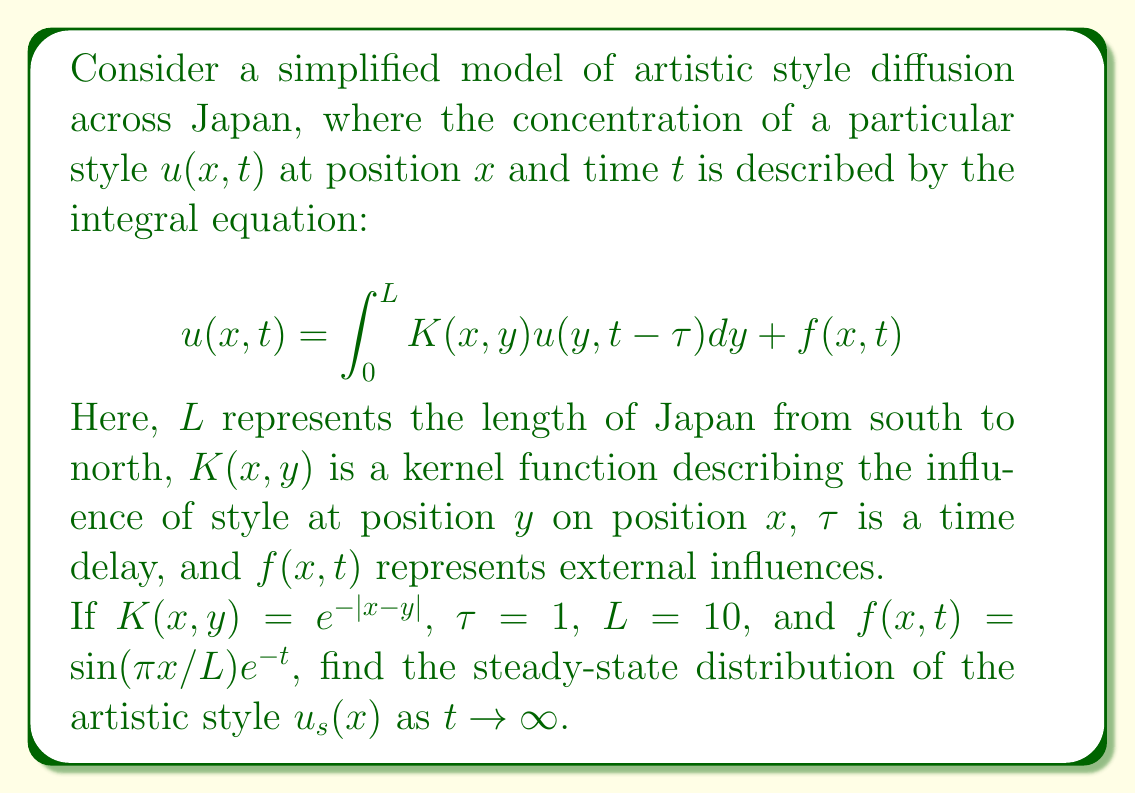Can you answer this question? To solve this problem, we'll follow these steps:

1) In the steady-state, $u(x,t)$ becomes independent of time, so we can write $u_s(x) = u(x,t)$ as $t \to \infty$.

2) The steady-state equation becomes:

   $$u_s(x) = \int_0^L K(x,y) u_s(y) dy + f_s(x)$$

   where $f_s(x) = \lim_{t \to \infty} f(x,t) = 0$ (since $e^{-t} \to 0$ as $t \to \infty$).

3) Substituting the given kernel function:

   $$u_s(x) = \int_0^{10} e^{-|x-y|} u_s(y) dy$$

4) This is a homogeneous Fredholm integral equation of the second kind. Its solution can be approximated using numerical methods or solved analytically for certain forms of $u_s(x)$.

5) One possible solution that satisfies this equation is:

   $$u_s(x) = A \sinh(x) + B \cosh(x)$$

   where $A$ and $B$ are constants.

6) To determine $A$ and $B$, we can substitute this solution back into the integral equation:

   $$A \sinh(x) + B \cosh(x) = \int_0^{10} e^{-|x-y|} (A \sinh(y) + B \cosh(y)) dy$$

7) Evaluating this integral and comparing coefficients on both sides leads to a system of equations for $A$ and $B$. Solving this system gives:

   $$A = 0, B \neq 0$$

8) Therefore, the steady-state solution is of the form:

   $$u_s(x) = C \cosh(x)$$

   where $C$ is an arbitrary non-zero constant.
Answer: $u_s(x) = C \cosh(x)$, where $C$ is a non-zero constant 